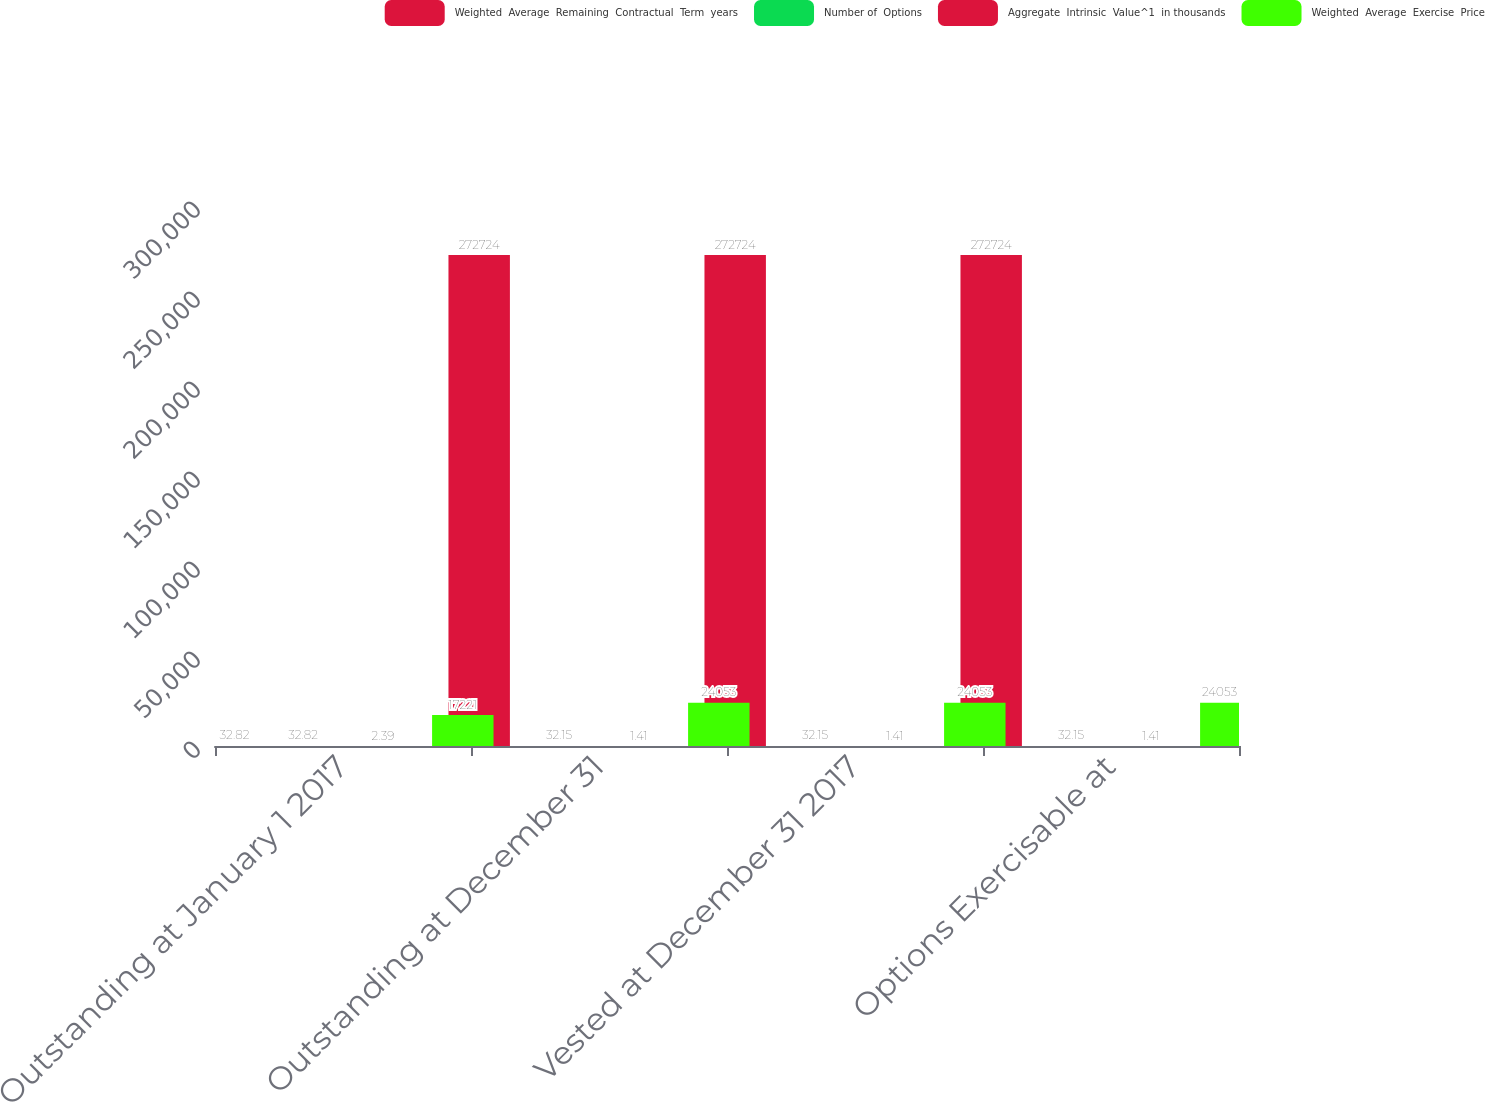<chart> <loc_0><loc_0><loc_500><loc_500><stacked_bar_chart><ecel><fcel>Outstanding at January 1 2017<fcel>Outstanding at December 31<fcel>Vested at December 31 2017<fcel>Options Exercisable at<nl><fcel>Weighted  Average  Remaining  Contractual  Term  years<fcel>32.82<fcel>272724<fcel>272724<fcel>272724<nl><fcel>Number of  Options<fcel>32.82<fcel>32.15<fcel>32.15<fcel>32.15<nl><fcel>Aggregate  Intrinsic  Value^1  in thousands<fcel>2.39<fcel>1.41<fcel>1.41<fcel>1.41<nl><fcel>Weighted  Average  Exercise  Price<fcel>17221<fcel>24053<fcel>24053<fcel>24053<nl></chart> 